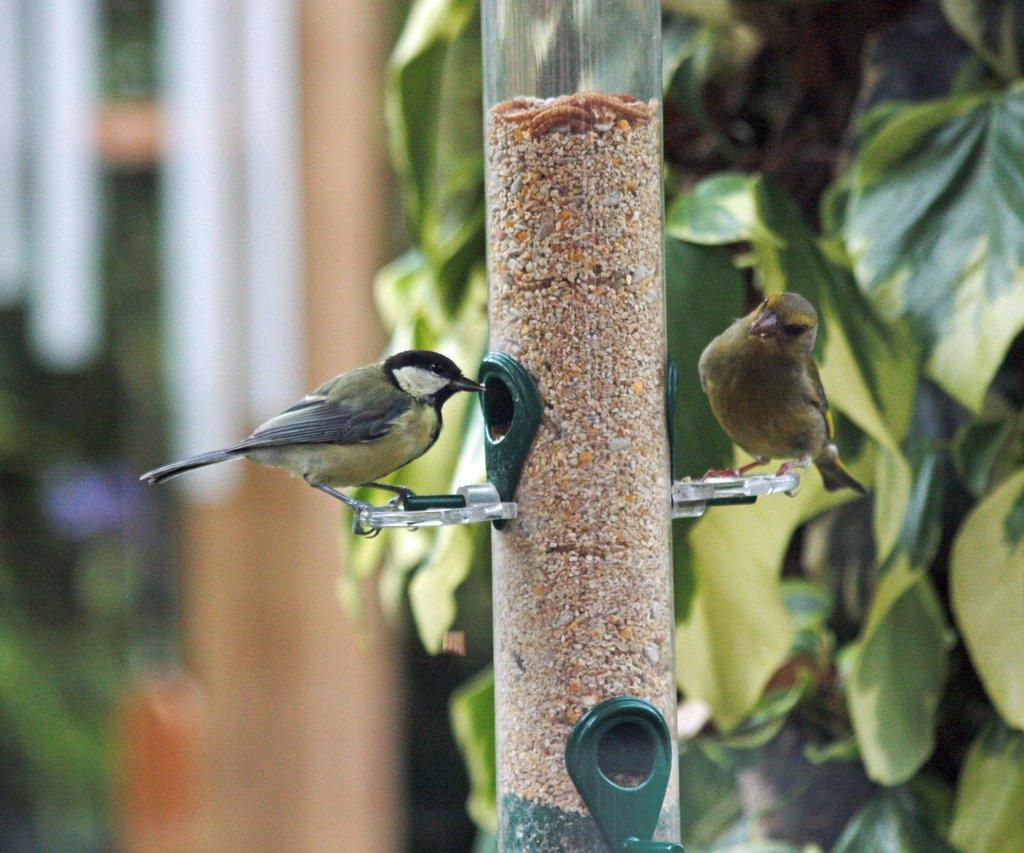Can you describe this image briefly? In this picture, we see two birds. Beside that, we see a pole. On the right side, we see a tree. There are buildings in the background. This picture is blurred in the background. 